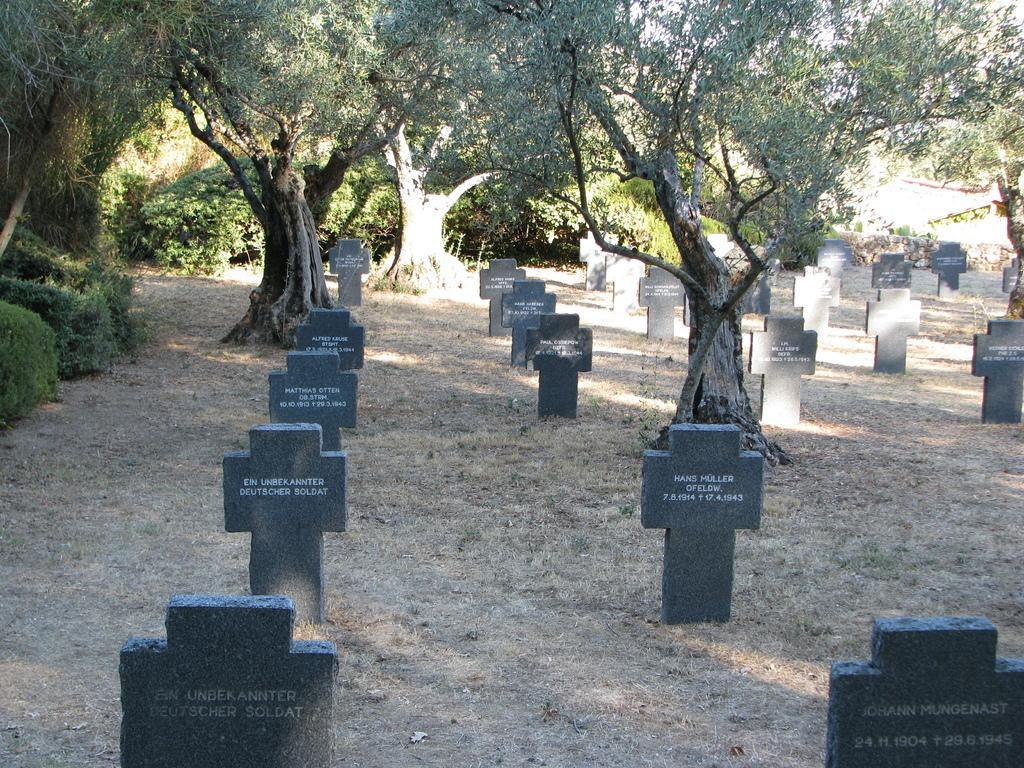Please provide a concise description of this image. This image is taken in the graveyard. At the bottom we can see graves. In the background there are trees. 